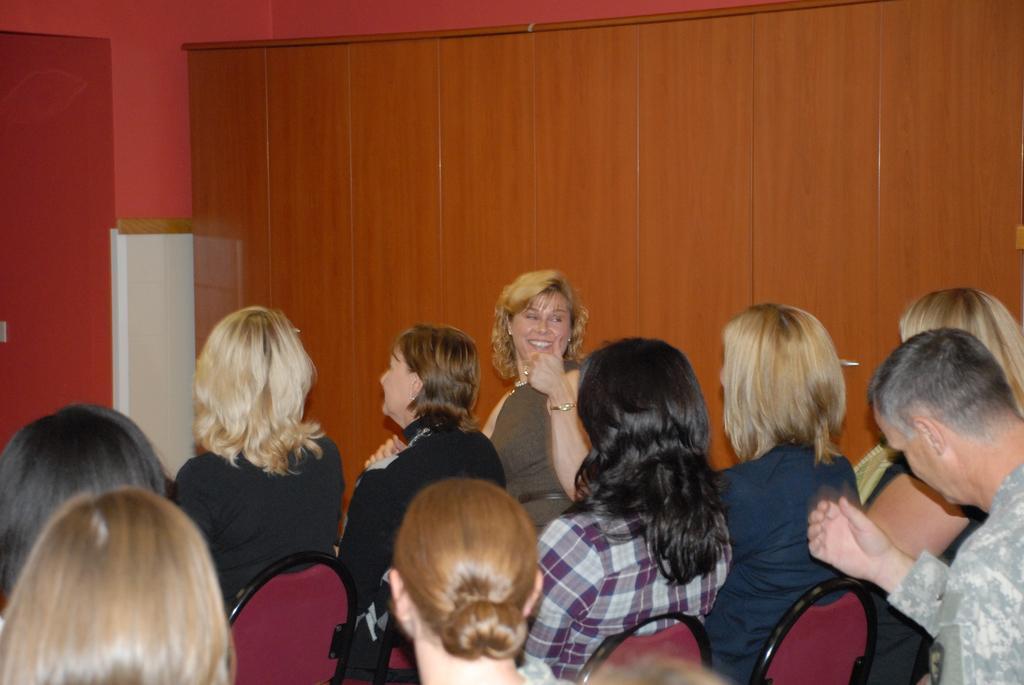Describe this image in one or two sentences. In this image we can see few people sitting on the chairs, there is a wooden object looks like a cupboard, there is a white color object near the cupboard and a wall in the background. 